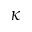Convert formula to latex. <formula><loc_0><loc_0><loc_500><loc_500>\kappa</formula> 